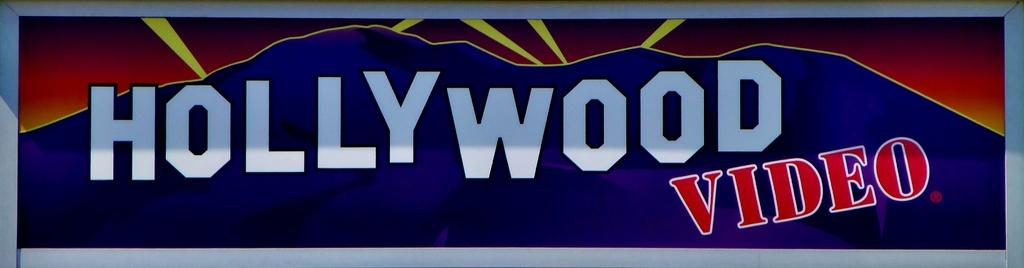<image>
Render a clear and concise summary of the photo. A Hollywood Video store sign with blue and red coloring 